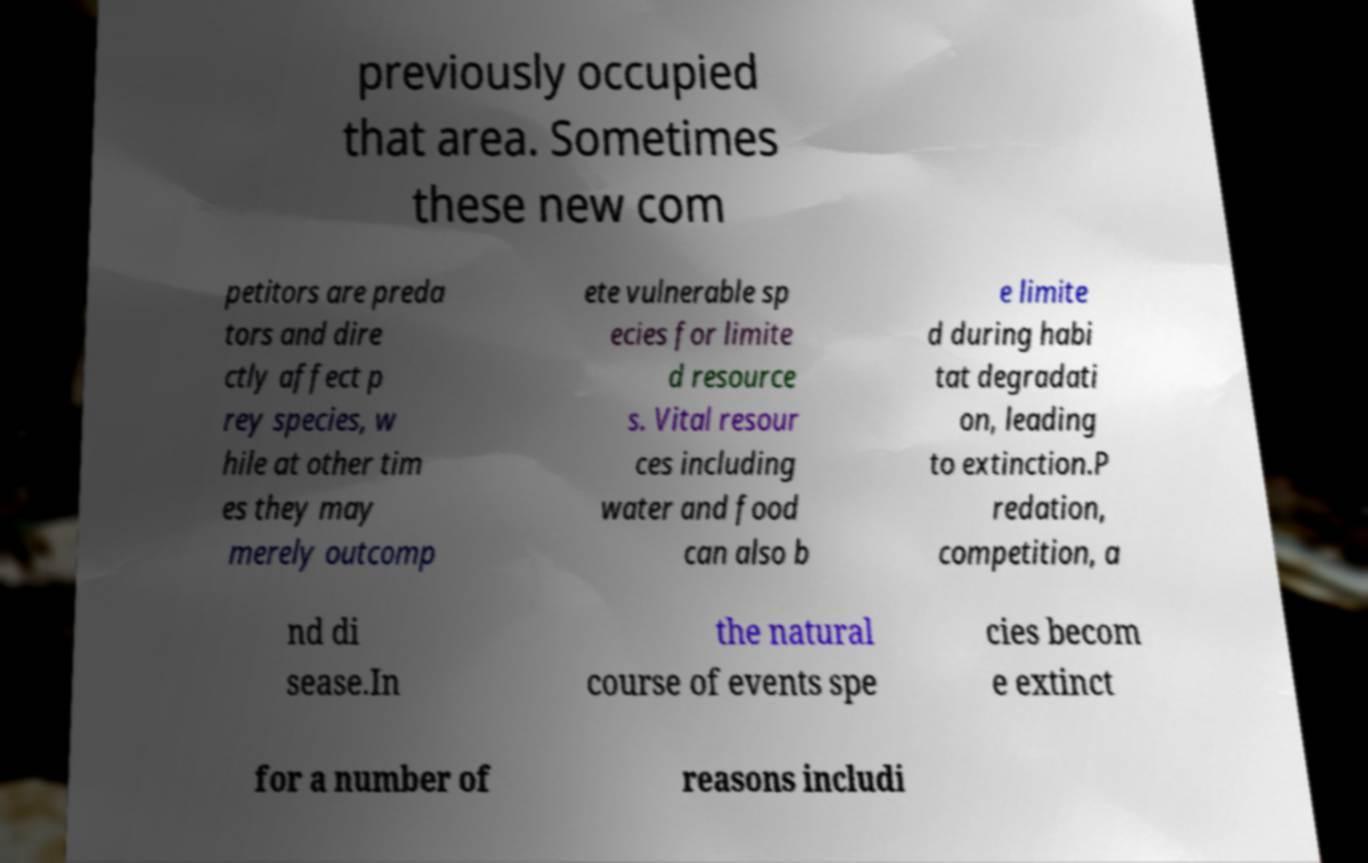Please identify and transcribe the text found in this image. previously occupied that area. Sometimes these new com petitors are preda tors and dire ctly affect p rey species, w hile at other tim es they may merely outcomp ete vulnerable sp ecies for limite d resource s. Vital resour ces including water and food can also b e limite d during habi tat degradati on, leading to extinction.P redation, competition, a nd di sease.In the natural course of events spe cies becom e extinct for a number of reasons includi 